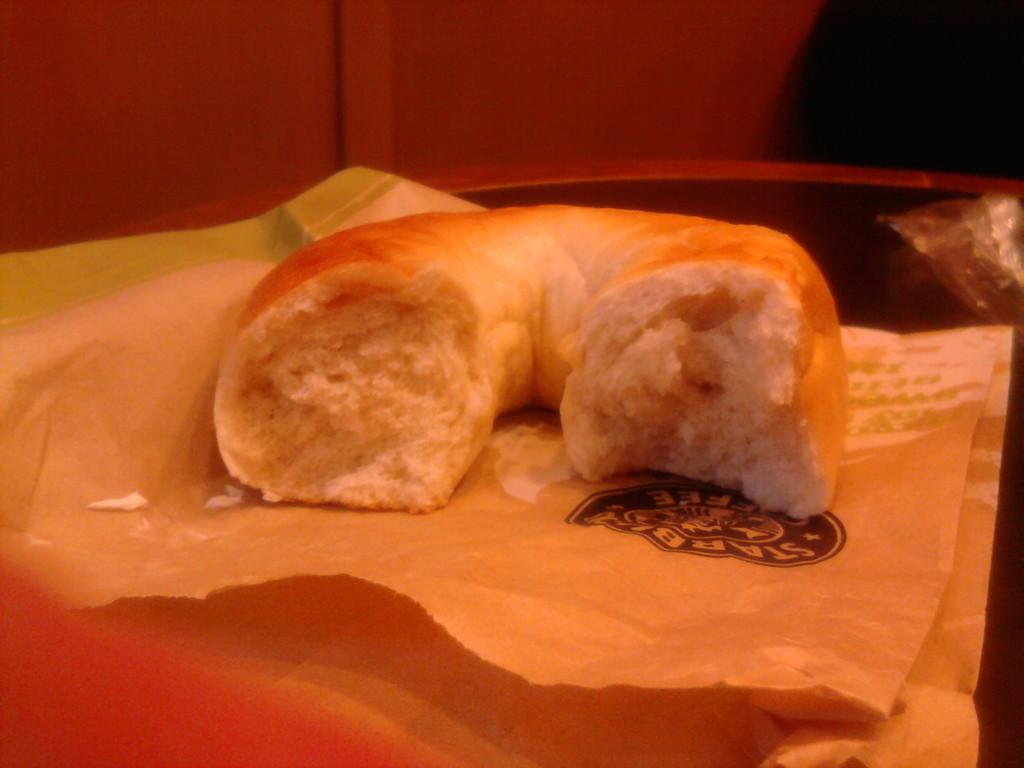Could you give a brief overview of what you see in this image? In this image we can see a half eaten food item kept on the paper which is placed on the table. In the background, we can see the wall. 